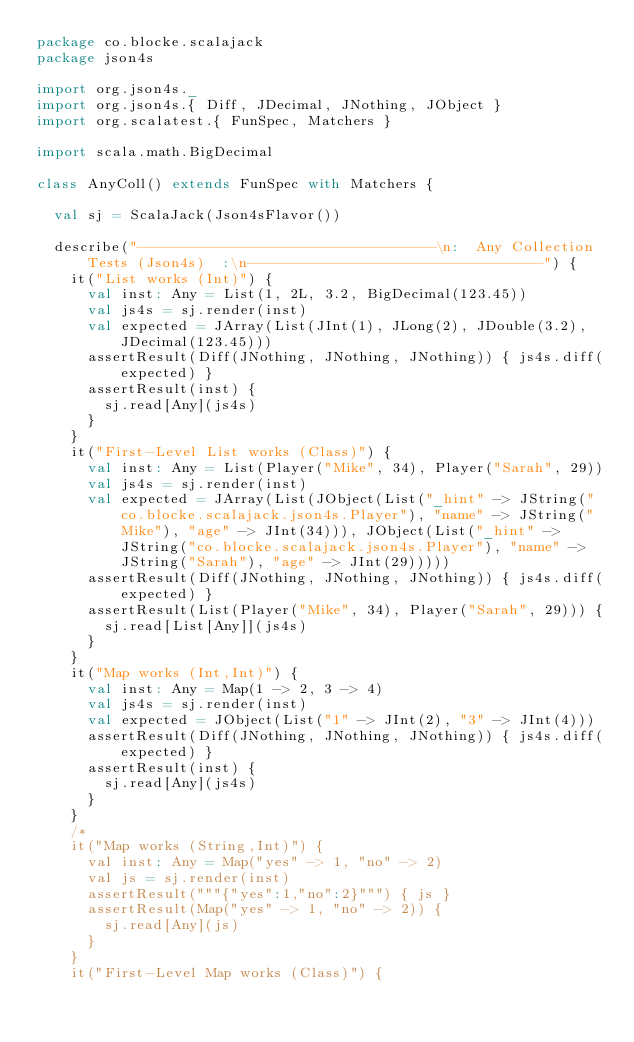<code> <loc_0><loc_0><loc_500><loc_500><_Scala_>package co.blocke.scalajack
package json4s

import org.json4s._
import org.json4s.{ Diff, JDecimal, JNothing, JObject }
import org.scalatest.{ FunSpec, Matchers }

import scala.math.BigDecimal

class AnyColl() extends FunSpec with Matchers {

  val sj = ScalaJack(Json4sFlavor())

  describe("-----------------------------------\n:  Any Collection Tests (Json4s)  :\n-----------------------------------") {
    it("List works (Int)") {
      val inst: Any = List(1, 2L, 3.2, BigDecimal(123.45))
      val js4s = sj.render(inst)
      val expected = JArray(List(JInt(1), JLong(2), JDouble(3.2), JDecimal(123.45)))
      assertResult(Diff(JNothing, JNothing, JNothing)) { js4s.diff(expected) }
      assertResult(inst) {
        sj.read[Any](js4s)
      }
    }
    it("First-Level List works (Class)") {
      val inst: Any = List(Player("Mike", 34), Player("Sarah", 29))
      val js4s = sj.render(inst)
      val expected = JArray(List(JObject(List("_hint" -> JString("co.blocke.scalajack.json4s.Player"), "name" -> JString("Mike"), "age" -> JInt(34))), JObject(List("_hint" -> JString("co.blocke.scalajack.json4s.Player"), "name" -> JString("Sarah"), "age" -> JInt(29)))))
      assertResult(Diff(JNothing, JNothing, JNothing)) { js4s.diff(expected) }
      assertResult(List(Player("Mike", 34), Player("Sarah", 29))) {
        sj.read[List[Any]](js4s)
      }
    }
    it("Map works (Int,Int)") {
      val inst: Any = Map(1 -> 2, 3 -> 4)
      val js4s = sj.render(inst)
      val expected = JObject(List("1" -> JInt(2), "3" -> JInt(4)))
      assertResult(Diff(JNothing, JNothing, JNothing)) { js4s.diff(expected) }
      assertResult(inst) {
        sj.read[Any](js4s)
      }
    }
    /*
    it("Map works (String,Int)") {
      val inst: Any = Map("yes" -> 1, "no" -> 2)
      val js = sj.render(inst)
      assertResult("""{"yes":1,"no":2}""") { js }
      assertResult(Map("yes" -> 1, "no" -> 2)) {
        sj.read[Any](js)
      }
    }
    it("First-Level Map works (Class)") {</code> 